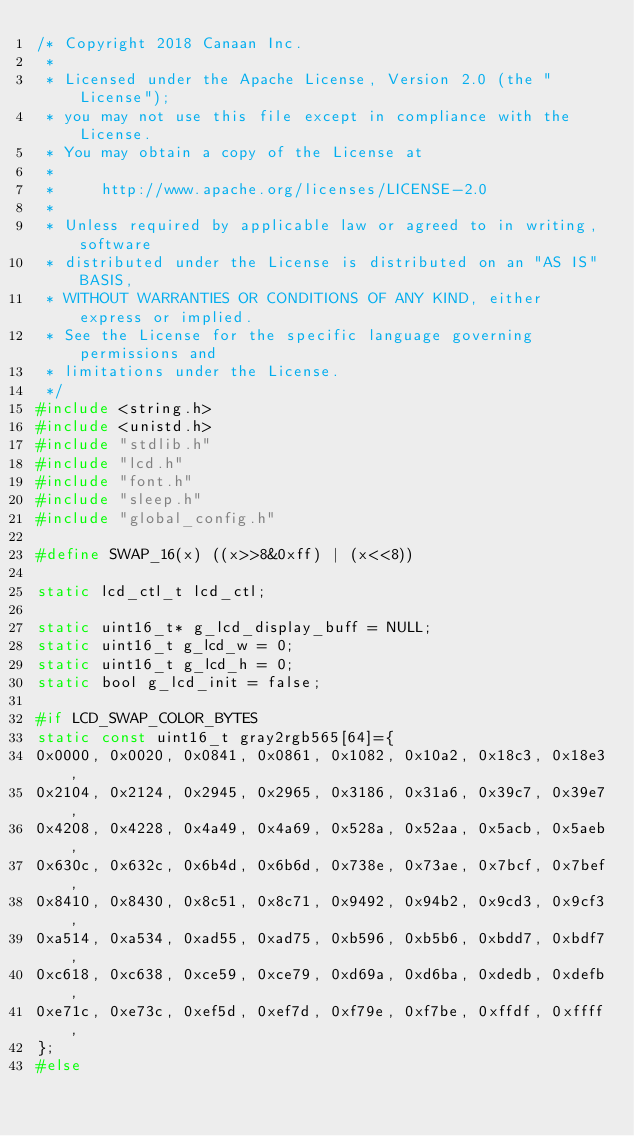<code> <loc_0><loc_0><loc_500><loc_500><_C_>/* Copyright 2018 Canaan Inc.
 *
 * Licensed under the Apache License, Version 2.0 (the "License");
 * you may not use this file except in compliance with the License.
 * You may obtain a copy of the License at
 *
 *     http://www.apache.org/licenses/LICENSE-2.0
 *
 * Unless required by applicable law or agreed to in writing, software
 * distributed under the License is distributed on an "AS IS" BASIS,
 * WITHOUT WARRANTIES OR CONDITIONS OF ANY KIND, either express or implied.
 * See the License for the specific language governing permissions and
 * limitations under the License.
 */
#include <string.h>
#include <unistd.h>
#include "stdlib.h"
#include "lcd.h"
#include "font.h"
#include "sleep.h"
#include "global_config.h"

#define SWAP_16(x) ((x>>8&0xff) | (x<<8))

static lcd_ctl_t lcd_ctl;

static uint16_t* g_lcd_display_buff = NULL;
static uint16_t g_lcd_w = 0;
static uint16_t g_lcd_h = 0;
static bool g_lcd_init = false;

#if LCD_SWAP_COLOR_BYTES
static const uint16_t gray2rgb565[64]={
0x0000, 0x0020, 0x0841, 0x0861, 0x1082, 0x10a2, 0x18c3, 0x18e3, 
0x2104, 0x2124, 0x2945, 0x2965, 0x3186, 0x31a6, 0x39c7, 0x39e7, 
0x4208, 0x4228, 0x4a49, 0x4a69, 0x528a, 0x52aa, 0x5acb, 0x5aeb, 
0x630c, 0x632c, 0x6b4d, 0x6b6d, 0x738e, 0x73ae, 0x7bcf, 0x7bef, 
0x8410, 0x8430, 0x8c51, 0x8c71, 0x9492, 0x94b2, 0x9cd3, 0x9cf3, 
0xa514, 0xa534, 0xad55, 0xad75, 0xb596, 0xb5b6, 0xbdd7, 0xbdf7, 
0xc618, 0xc638, 0xce59, 0xce79, 0xd69a, 0xd6ba, 0xdedb, 0xdefb, 
0xe71c, 0xe73c, 0xef5d, 0xef7d, 0xf79e, 0xf7be, 0xffdf, 0xffff,
};
#else</code> 